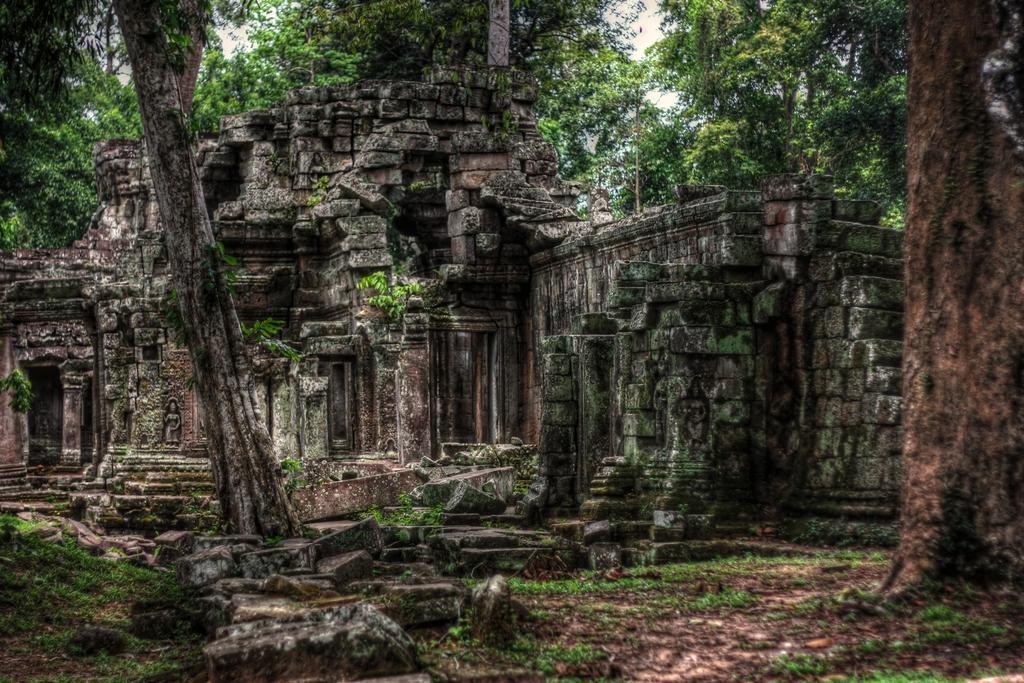Could you give a brief overview of what you see in this image? In this picture I can see a monument, few trees and grass on the ground. 